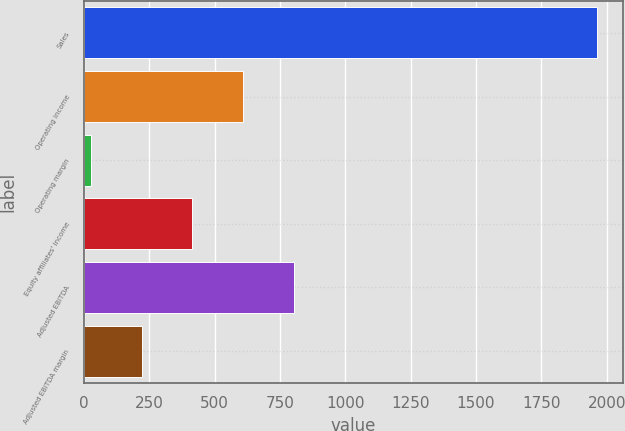<chart> <loc_0><loc_0><loc_500><loc_500><bar_chart><fcel>Sales<fcel>Operating income<fcel>Operating margin<fcel>Equity affiliates' income<fcel>Adjusted EBITDA<fcel>Adjusted EBITDA margin<nl><fcel>1964.7<fcel>608.31<fcel>27<fcel>414.54<fcel>802.08<fcel>220.77<nl></chart> 